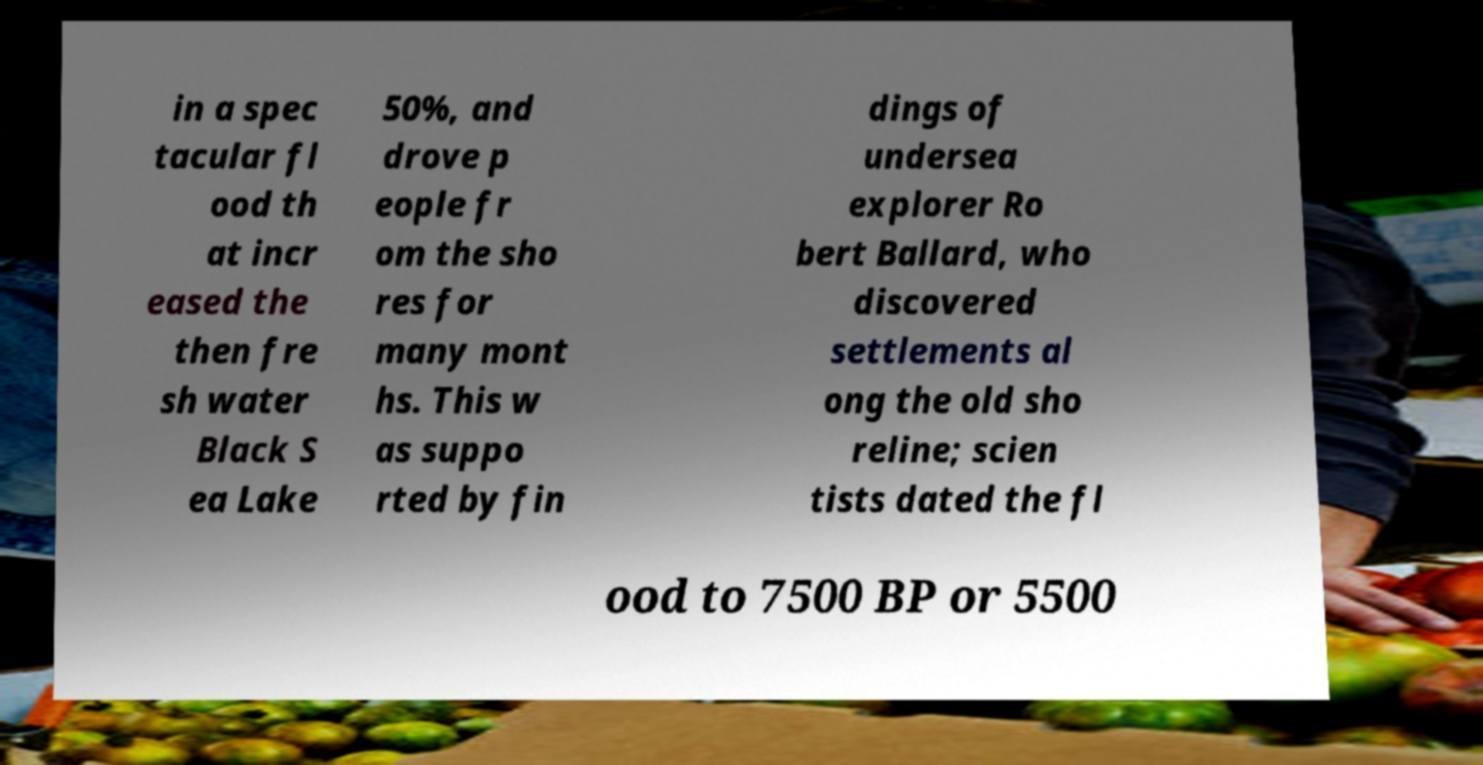Can you accurately transcribe the text from the provided image for me? in a spec tacular fl ood th at incr eased the then fre sh water Black S ea Lake 50%, and drove p eople fr om the sho res for many mont hs. This w as suppo rted by fin dings of undersea explorer Ro bert Ballard, who discovered settlements al ong the old sho reline; scien tists dated the fl ood to 7500 BP or 5500 